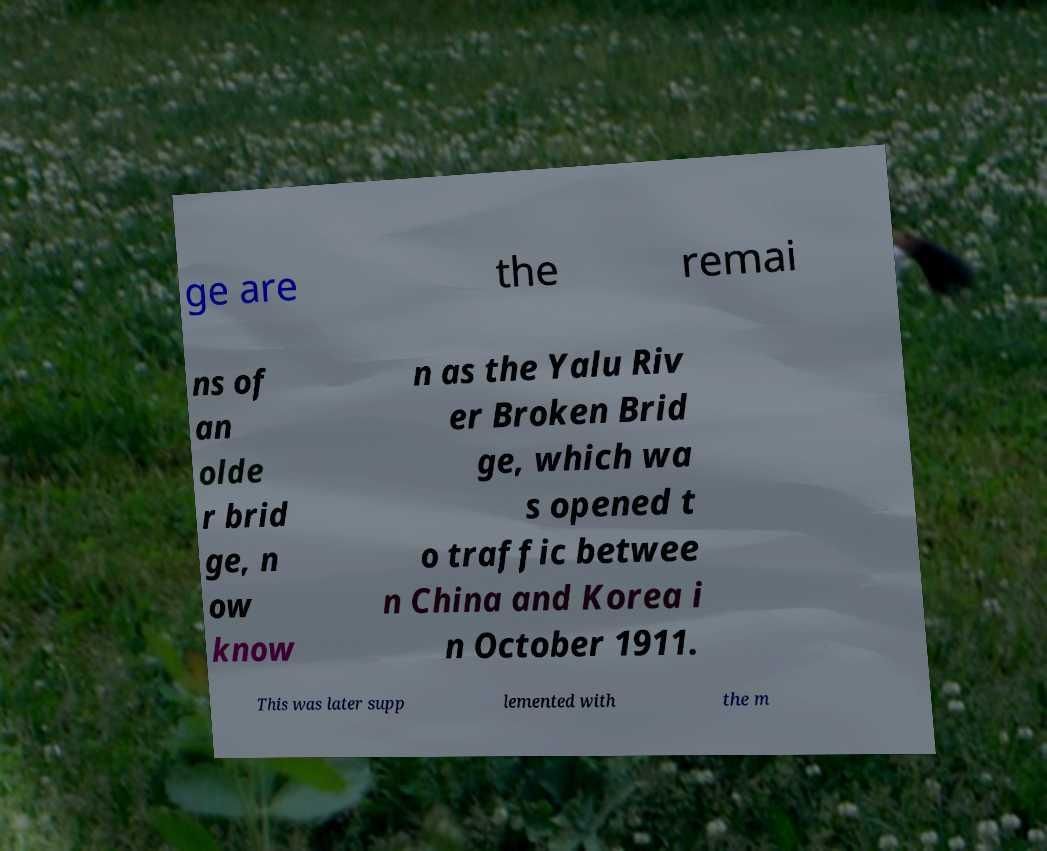I need the written content from this picture converted into text. Can you do that? ge are the remai ns of an olde r brid ge, n ow know n as the Yalu Riv er Broken Brid ge, which wa s opened t o traffic betwee n China and Korea i n October 1911. This was later supp lemented with the m 